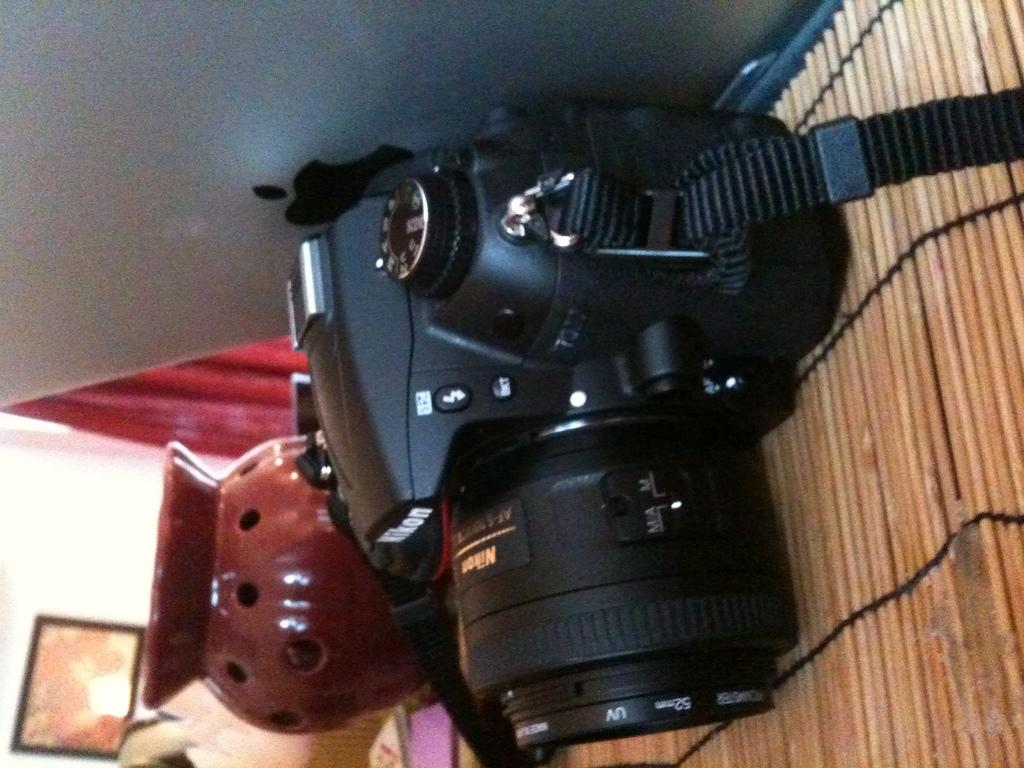What electronic device can be seen in the image? There is a camera and a laptop in the image. What type of container is visible in the image? There is a pot in the image. What type of window treatment is present in the image? There is a curtain in the image. What is hanging on the wall in the image? There is a frame on the wall in the image. What other unspecified objects can be seen in the image? There are some unspecified objects in the image. What type of lace can be seen on the camera in the image? There is no lace present on the camera in the image. What type of pipe is visible in the image? There is no pipe visible in the image. 